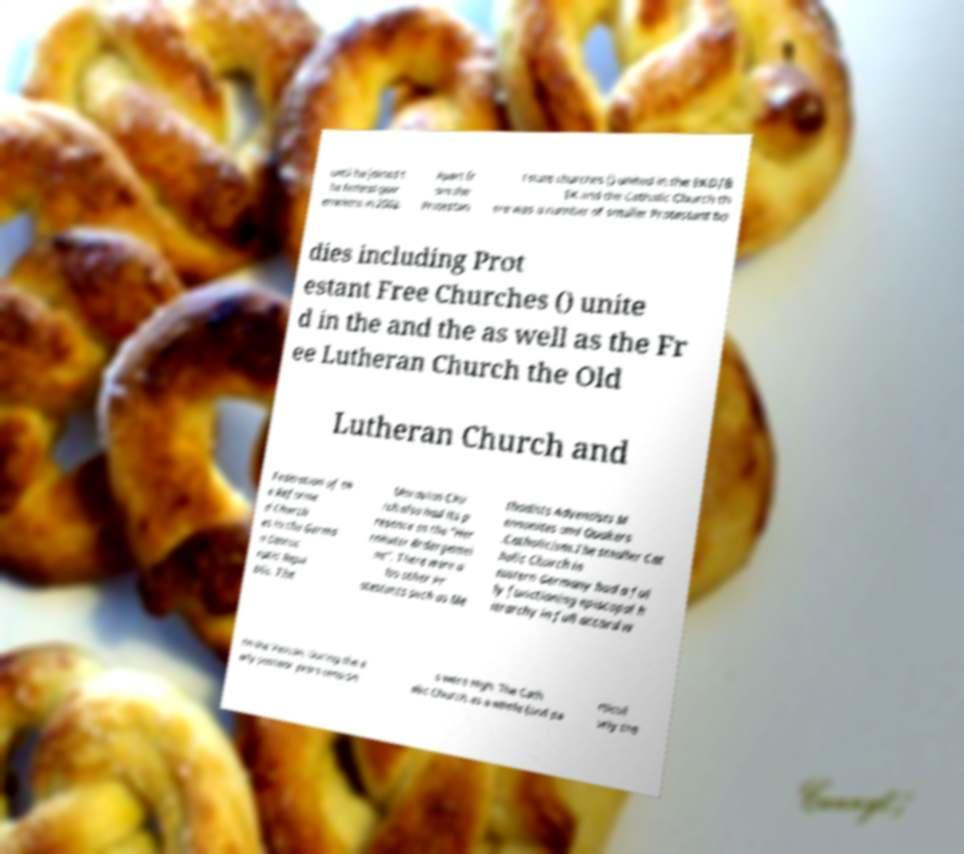Could you assist in decoding the text presented in this image and type it out clearly? until he joined t he federal gov ernment in 2002. Apart fr om the Protestan t state churches () united in the EKD/B EK and the Catholic Church th ere was a number of smaller Protestant bo dies including Prot estant Free Churches () unite d in the and the as well as the Fr ee Lutheran Church the Old Lutheran Church and Federation of th e Reforme d Church es in the Germa n Democ ratic Repu blic. The Moravian Chu rch also had its p resence as the "Her rnhuter Brdergemei ne". There were a lso other Pr otestants such as Me thodists Adventists M ennonites and Quakers .Catholicism.The smaller Cat holic Church in eastern Germany had a ful ly functioning episcopal h ierarchy in full accord w ith the Vatican. During the e arly postwar years tension s were high. The Cath olic Church as a whole (and pa rticul arly the 